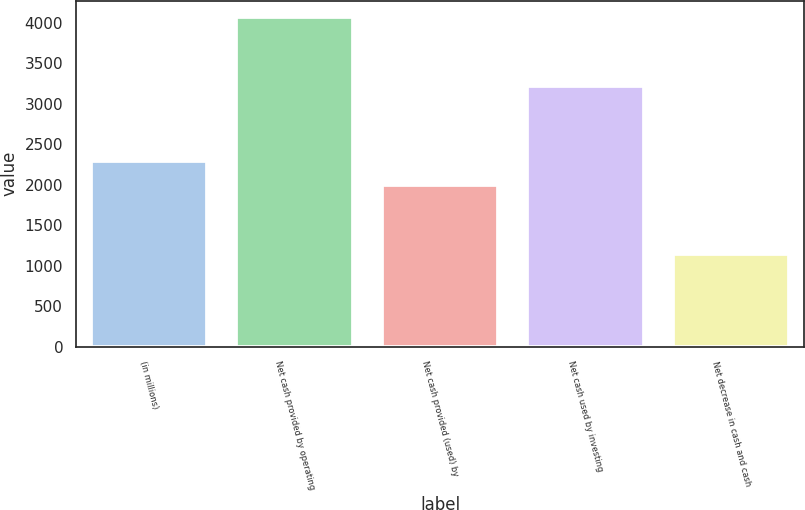Convert chart to OTSL. <chart><loc_0><loc_0><loc_500><loc_500><bar_chart><fcel>(in millions)<fcel>Net cash provided by operating<fcel>Net cash provided (used) by<fcel>Net cash used by investing<fcel>Net decrease in cash and cash<nl><fcel>2291<fcel>4069<fcel>1999<fcel>3219<fcel>1149<nl></chart> 